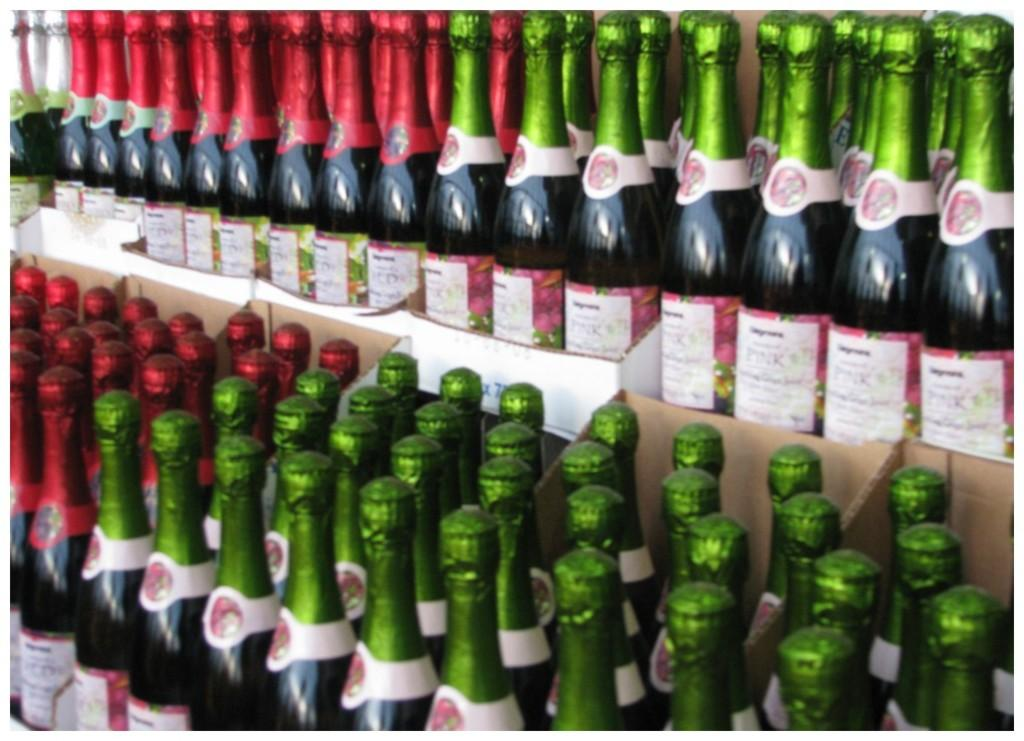<image>
Describe the image concisely. Many bottles inside crates with labels that read Pink on them. 